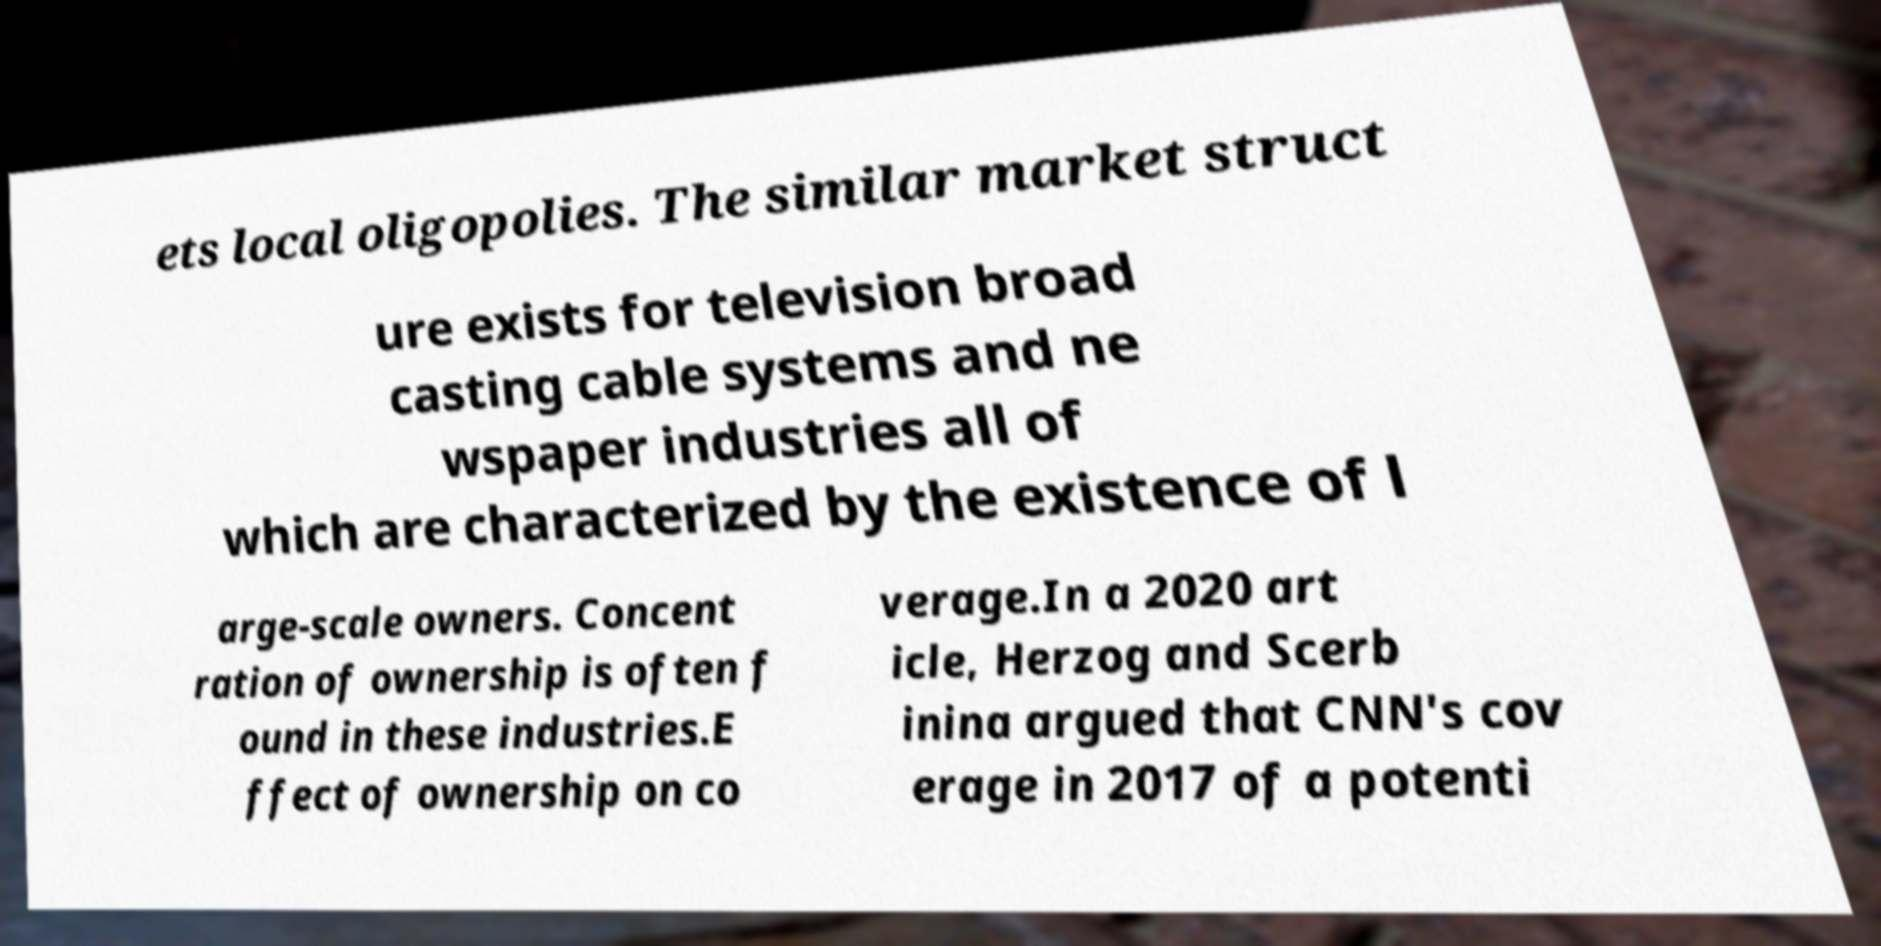Can you read and provide the text displayed in the image?This photo seems to have some interesting text. Can you extract and type it out for me? ets local oligopolies. The similar market struct ure exists for television broad casting cable systems and ne wspaper industries all of which are characterized by the existence of l arge-scale owners. Concent ration of ownership is often f ound in these industries.E ffect of ownership on co verage.In a 2020 art icle, Herzog and Scerb inina argued that CNN's cov erage in 2017 of a potenti 